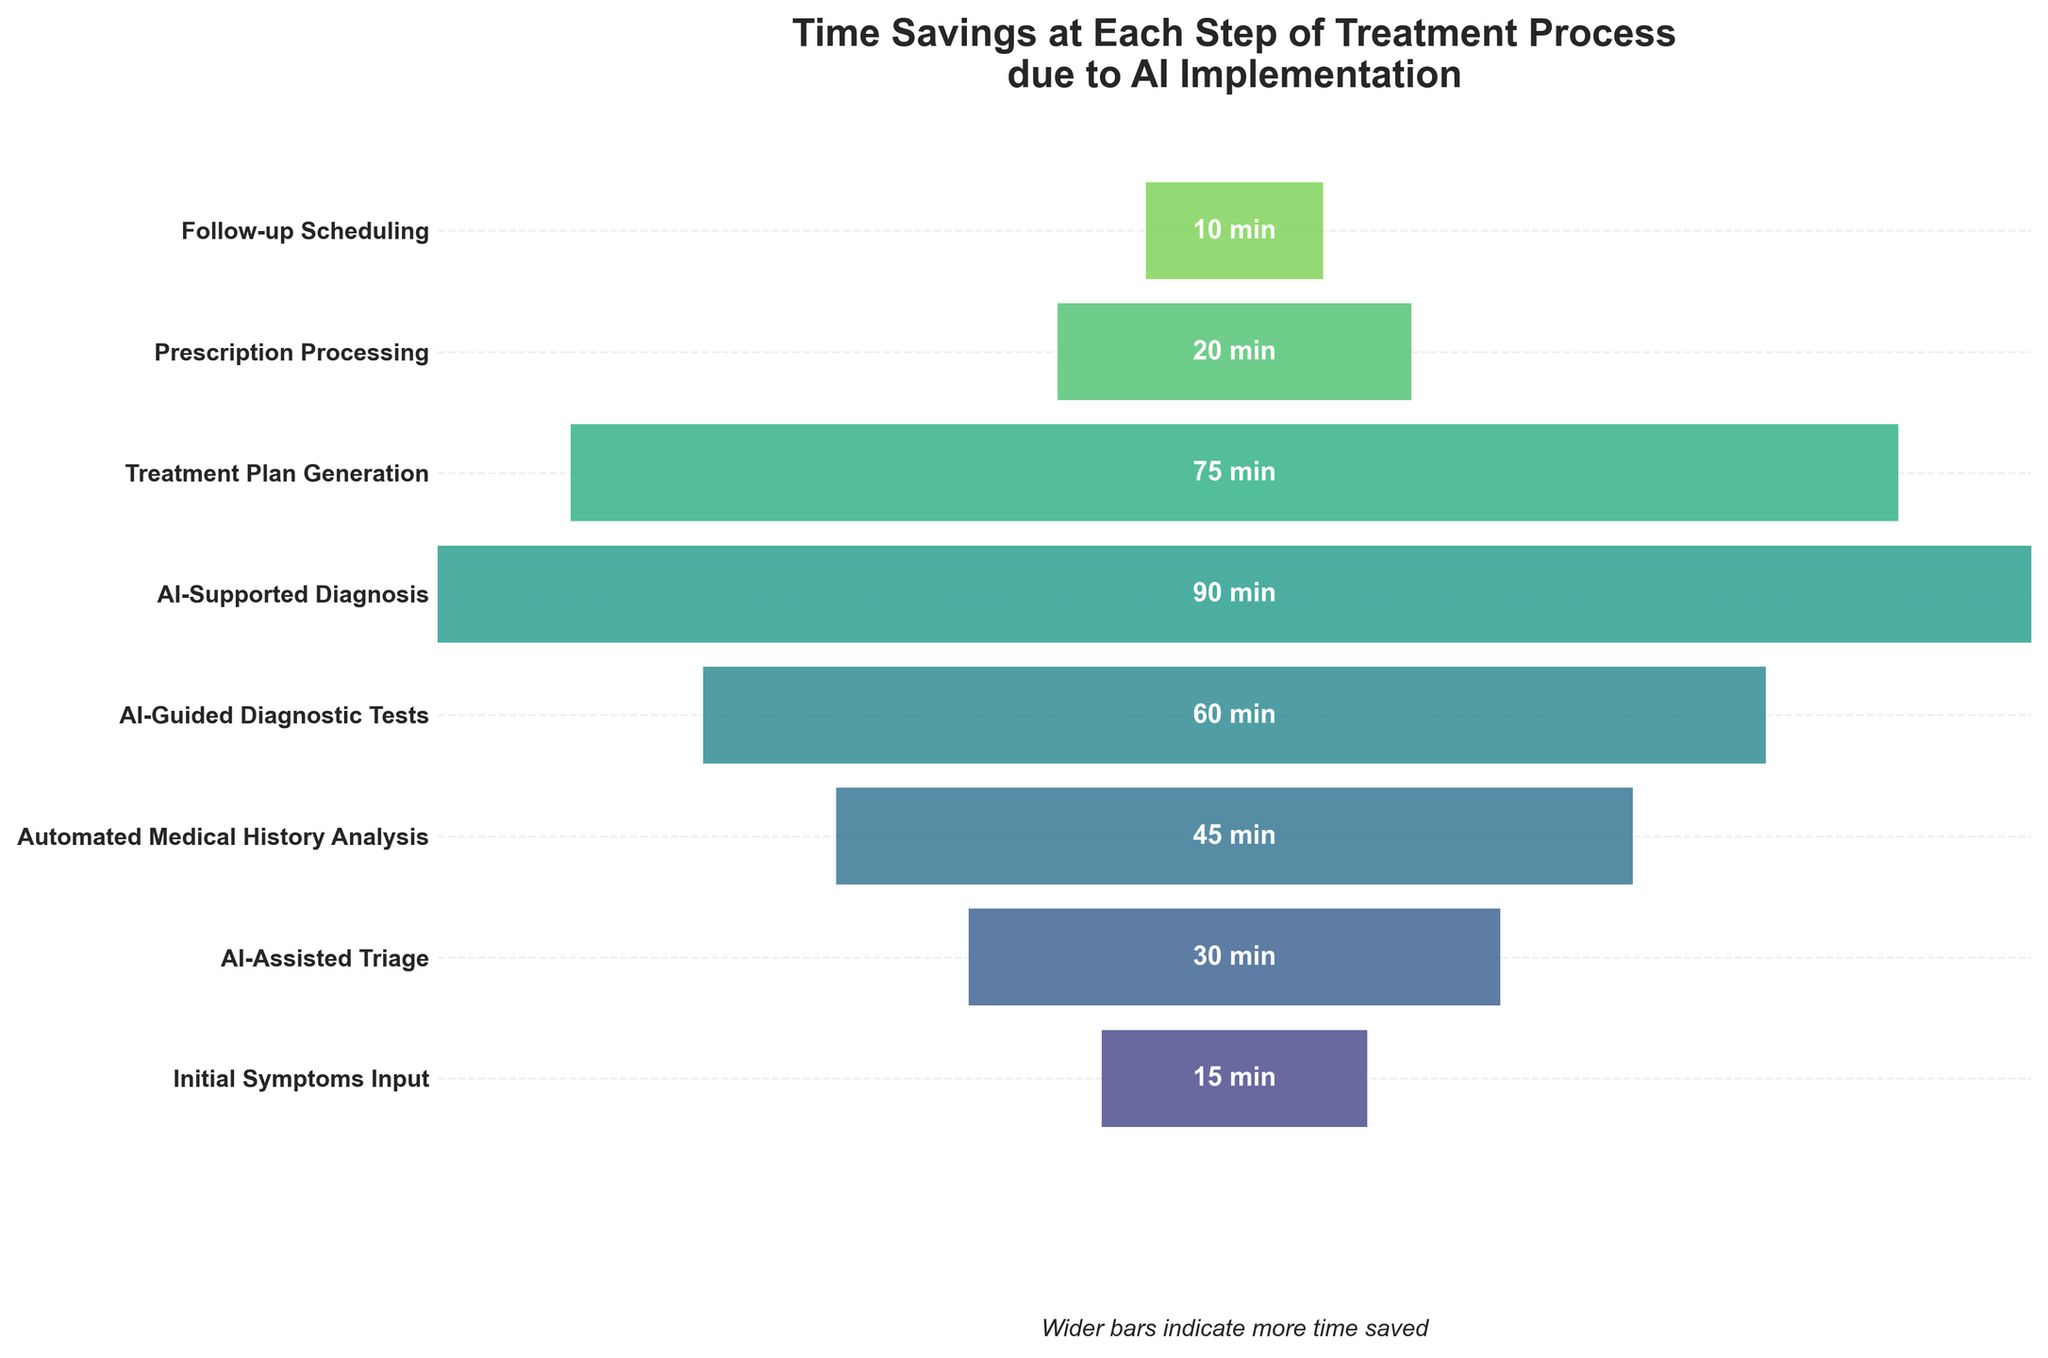What does the figure title indicate? The title of the figure is "Time Savings at Each Step of Treatment Process due to AI Implementation," which indicates that the plot shows the amount of time saved at each step in the treatment process because of AI.
Answer: Time savings at each step due to AI What is the maximum time saved in a single step? The bar associated with "AI-Supported Diagnosis" is the widest and has 90 minutes labeled on it, indicating that this step saves the maximum amount of time.
Answer: 90 minutes Which step saves the least amount of time? The bar corresponding to "Follow-up Scheduling" is the narrowest and has 10 minutes labeled on it, indicating it saves the least amount of time.
Answer: 10 minutes How many steps are represented in the funnel chart? The y-axis has eight tick labels corresponding to eight different steps in the treatment process.
Answer: 8 steps How much total time is saved across all steps? Add the time saved for each step: 15 + 30 + 45 + 60 + 90 + 75 + 20 + 10 = 345 minutes.
Answer: 345 minutes What is the average time saved per step? The total time saved is 345 minutes for 8 steps, so the average time saved per step is 345 / 8 = 43.125 minutes.
Answer: Approximately 43.13 minutes Is the time saved in "AI-Guided Diagnostic Tests" greater than in "Treatment Plan Generation"? The time saved for "AI-Guided Diagnostic Tests" is 60 minutes, while for "Treatment Plan Generation" it is 75 minutes; thus, the time saved in "AI-Guided Diagnostic Tests" is less.
Answer: No Which step follows "AI-Assisted Triage" in terms of time saved? Based on the order of the labels, "Automated Medical History Analysis" follows "AI-Assisted Triage."
Answer: Automated Medical History Analysis What is the difference in time saved between "AI-Supported Diagnosis" and "Prescription Processing"? The time saved for "AI-Supported Diagnosis" is 90 minutes and for "Prescription Processing" is 20 minutes, so the difference is 90 - 20 = 70 minutes.
Answer: 70 minutes Is the time saved in "Initial Symptoms Input" and "Prescription Processing" combined greater than the time saved in "AI-Guided Diagnostic Tests"? The combined time saved for "Initial Symptoms Input" (15 minutes) and "Prescription Processing" (20 minutes) is 35 minutes, which is less than the 60 minutes saved for "AI-Guided Diagnostic Tests".
Answer: No 